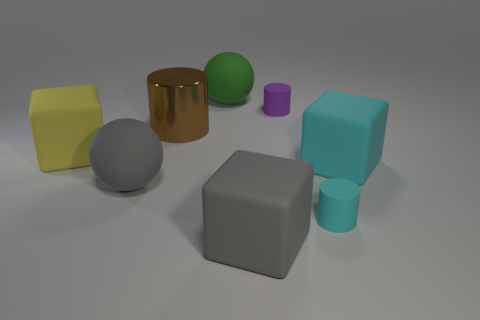Subtract all tiny cyan matte cylinders. How many cylinders are left? 2 Subtract all brown cylinders. How many cylinders are left? 2 Add 2 large brown objects. How many objects exist? 10 Subtract 3 cylinders. How many cylinders are left? 0 Subtract all cylinders. How many objects are left? 5 Subtract all gray cylinders. Subtract all purple cubes. How many cylinders are left? 3 Add 6 large rubber spheres. How many large rubber spheres are left? 8 Add 3 shiny cylinders. How many shiny cylinders exist? 4 Subtract 0 yellow spheres. How many objects are left? 8 Subtract all cyan cylinders. How many cyan blocks are left? 1 